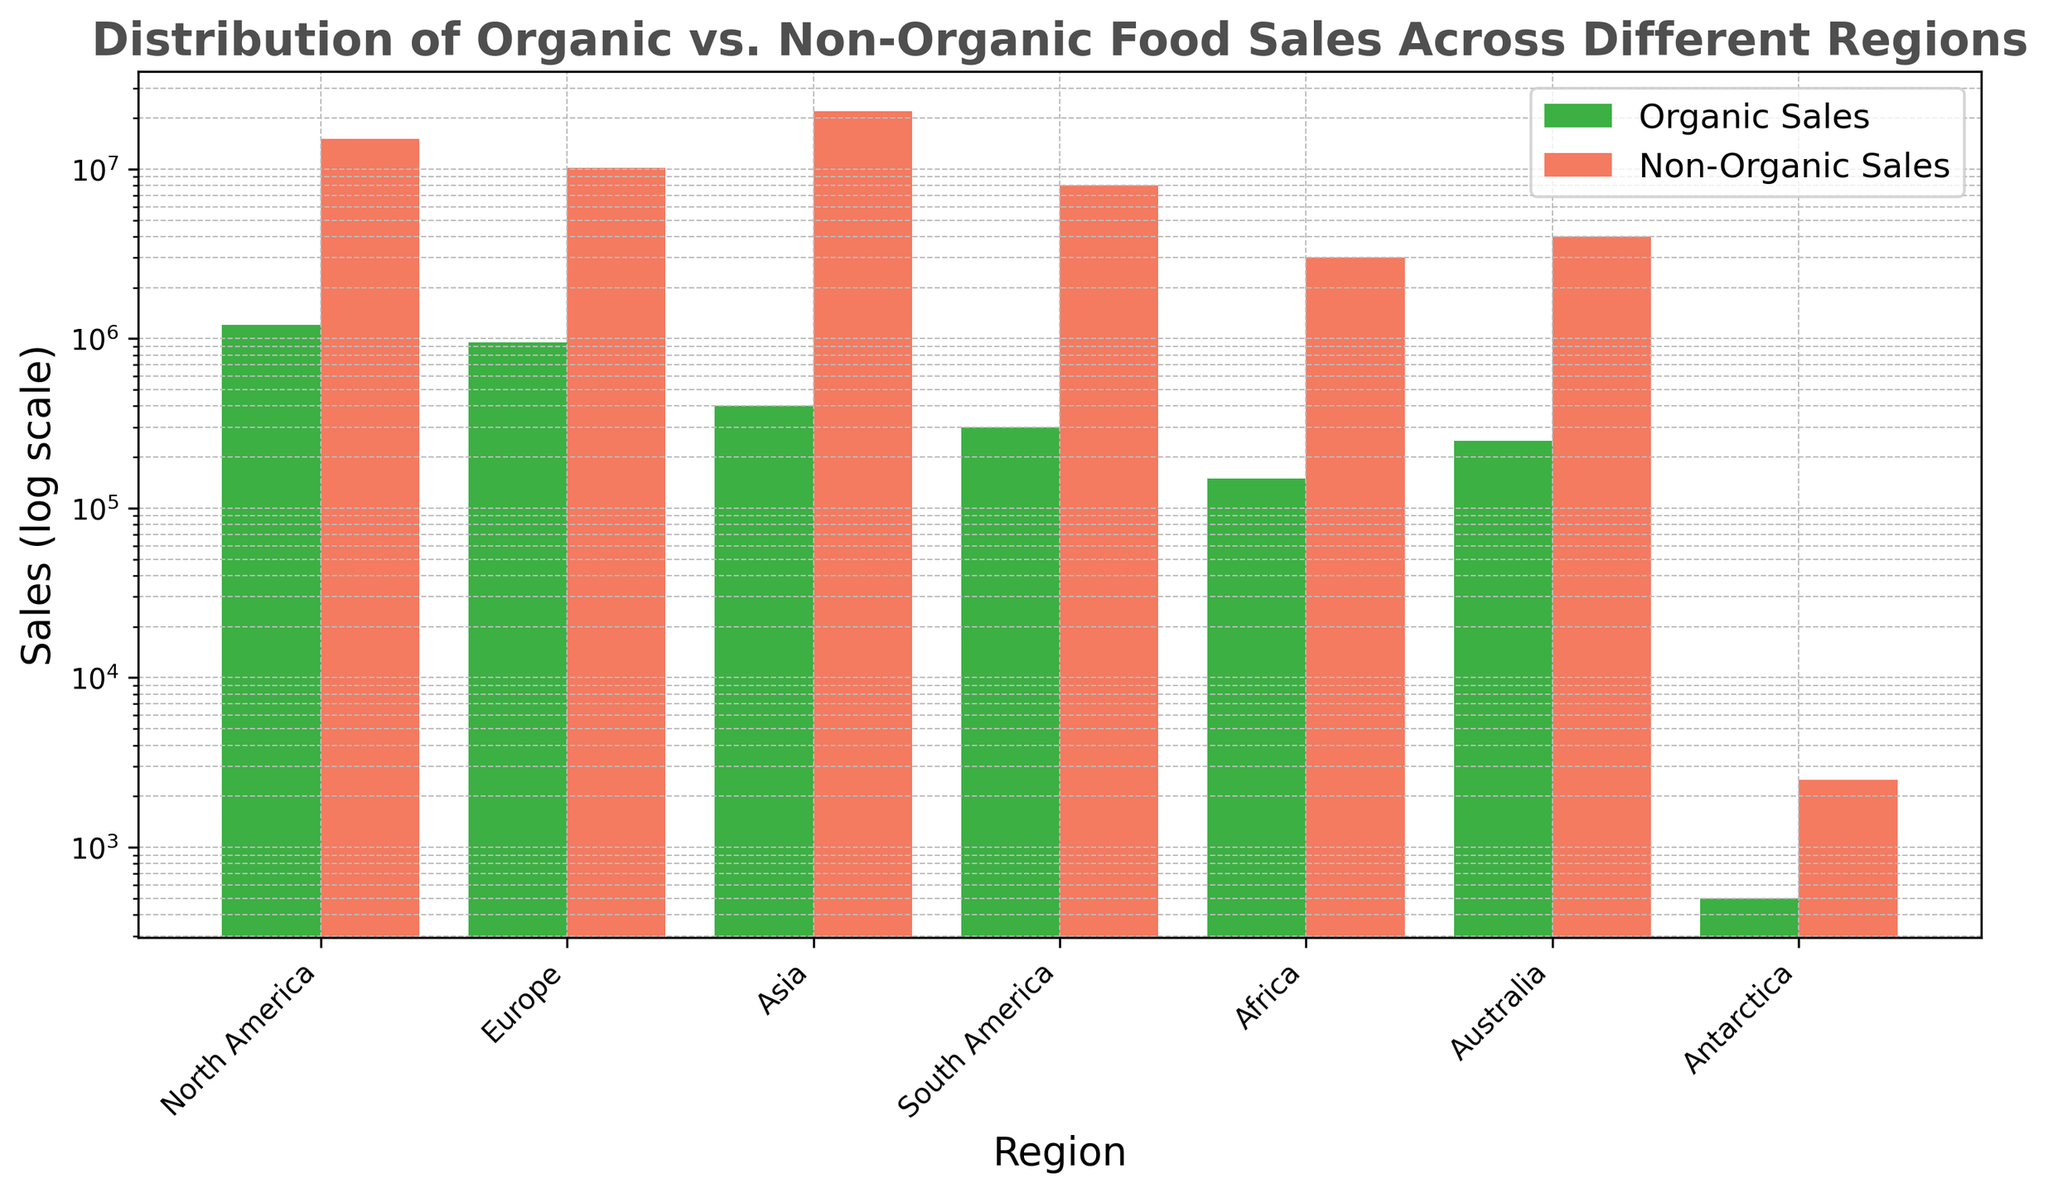Which region has the highest non-organic food sales? Observe the heights of the bars for non-organic food sales, which are colored red. The tallest bar is for Asia.
Answer: Asia Which region has the smallest organic food sales? Compare the heights of the bars for organic food sales, colored green. The smallest bar belongs to Antarctica.
Answer: Antarctica What is the difference in non-organic food sales between North America and Africa? Look at the heights of the red bars for North America and Africa. North America's non-organic sales are 15,000,000 and Africa's are 3,000,000. The difference is 15,000,000 - 3,000,000 = 12,000,000.
Answer: 12,000,000 How many times greater are the organic sales in Europe compared to Antarctica? Organic sales in Europe are 950,000 and in Antarctica, they are 500. The ratio is 950,000 / 500 which equals 1,900 times.
Answer: 1900 times Which region has the closest organic and non-organic sales? Compare the difference in the heights of green and red bars for each region. Antarctica shows the smallest difference between the two.
Answer: Antarctica What is the combined sales of organic food in North America and Europe? Add the organic sales for both regions: 1,200,000 (North America) + 950,000 (Europe) = 2,150,000.
Answer: 2,150,000 How do the non-organic sales in South America compare to those in Australia? Look at the red bars for South America and Australia. South America's non-organic sales are 8,000,000 and Australia's are 4,000,000. South America has 4,000,000 more sales.
Answer: South America has 4,000,000 more sales What is the average non-organic food sales per region? Sum all the non-organic sales and divide by the number of regions. (15,000,000 + 10,200,000 + 22,000,000 + 8,000,000 + 3,000,000 + 4,000,000 + 2,500) / 7 ≈ 8,457,857.14
Answer: ≈ 8,457,857.14 Which region shows a higher difference between organic and non-organic sales: Asia or Europe? Calculate the differences: Asia (22,000,000 - 400,000 = 21,600,000) and Europe (10,200,000 - 950,000 = 9,250,000). Asia has a higher difference.
Answer: Asia 